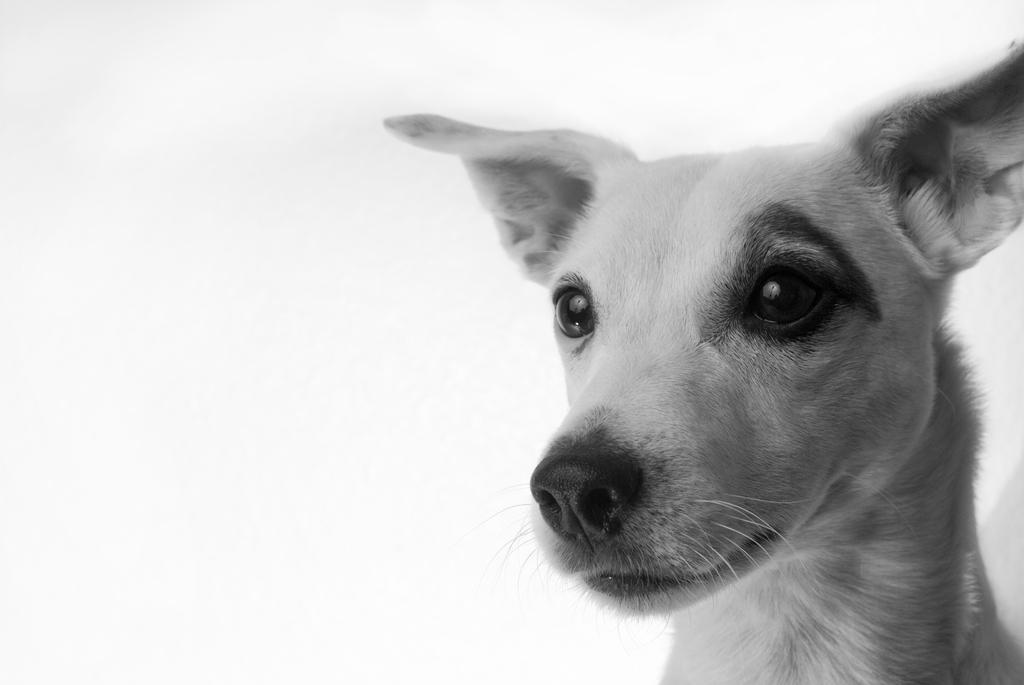What type of animal is in the image? There is a dog in the image. Can you describe the color pattern of the dog? The dog is white and black in color. What is the background of the image? The background of the image is white. How many veins can be seen on the dog's body in the image? There are no veins visible on the dog's body in the image. 